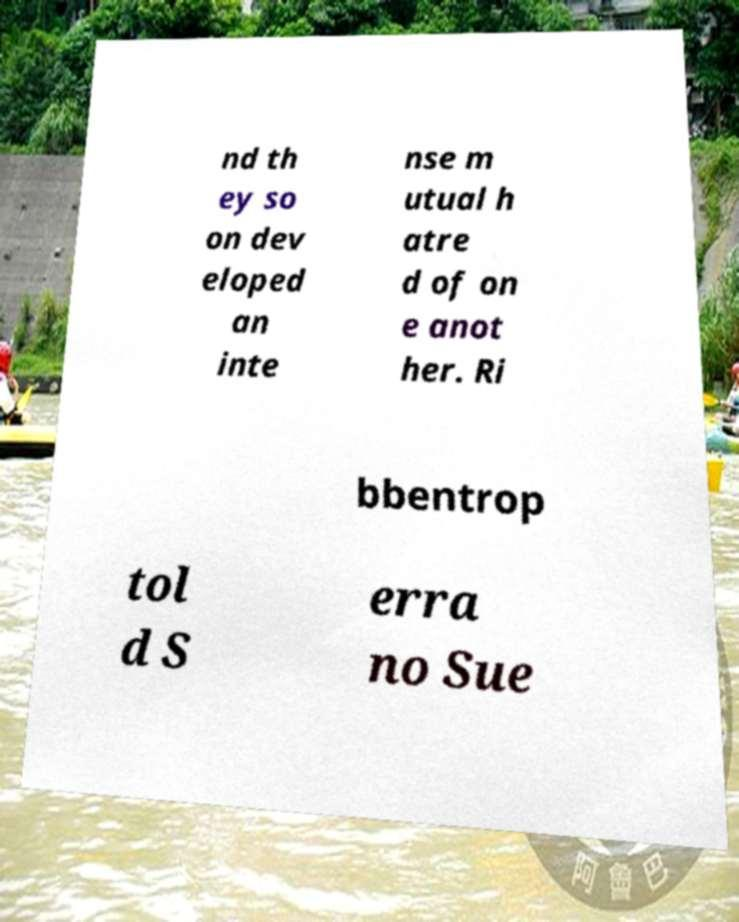Could you extract and type out the text from this image? nd th ey so on dev eloped an inte nse m utual h atre d of on e anot her. Ri bbentrop tol d S erra no Sue 